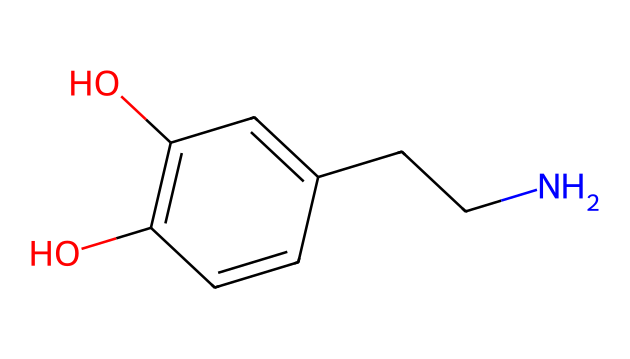What is the molecular formula of this chemical? By analyzing the atoms present in the chemical structure provided in SMILES, we can count the number of each type of atom. The structure indicates a total of 11 carbon atoms (C), 15 hydrogen atoms (H), 2 oxygen atoms (O), and 1 nitrogen atom (N). Therefore, the molecular formula is C11H15N2O2.
Answer: C11H15N2O2 How many rings are in the chemical structure? The chemical structure presented does not show any rings. In the provided SMILES, there is only a linear arrangement of atoms without circular connections, indicating that there are no rings present.
Answer: 0 What functional groups are present in this chemical? In analyzing the structure, we notice the presence of hydroxyl (-OH) groups indicated by the 'O' atoms connected to 'C' atoms. There are two such groups in this structure. Additionally, the presence of a nitrogen atom connected to carbon hints at an amine functional group. Thus, the chemical has hydroxyl and amine functional groups.
Answer: hydroxyl, amine Is this chemical likely to affect dopamine levels? The presence of functional groups such as amines is commonly associated with neurotransmitter activity in the brain. This chemical contains an amine group, which could suggest a potential impact on dopamine levels, showing its role in reward and pleasure mechanisms.
Answer: yes What type of compound is this chemical classified as? Based on the functional groups and structure, this compound is classified as a phenolic compound due to the presence of a phenyl group along with hydroxyl groups. It is also considered an amine due to the nitrogen presence.
Answer: phenolic amine How many total hydrogen and oxygen atoms are there? To find the total number of hydrogen and oxygen atoms, we can count from the molecular formula obtained earlier: there are 15 hydrogen atoms and 2 oxygen atoms in the chemical. Adding these together, we have a total of 17.
Answer: 17 